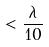<formula> <loc_0><loc_0><loc_500><loc_500>< \frac { \lambda } { 1 0 }</formula> 